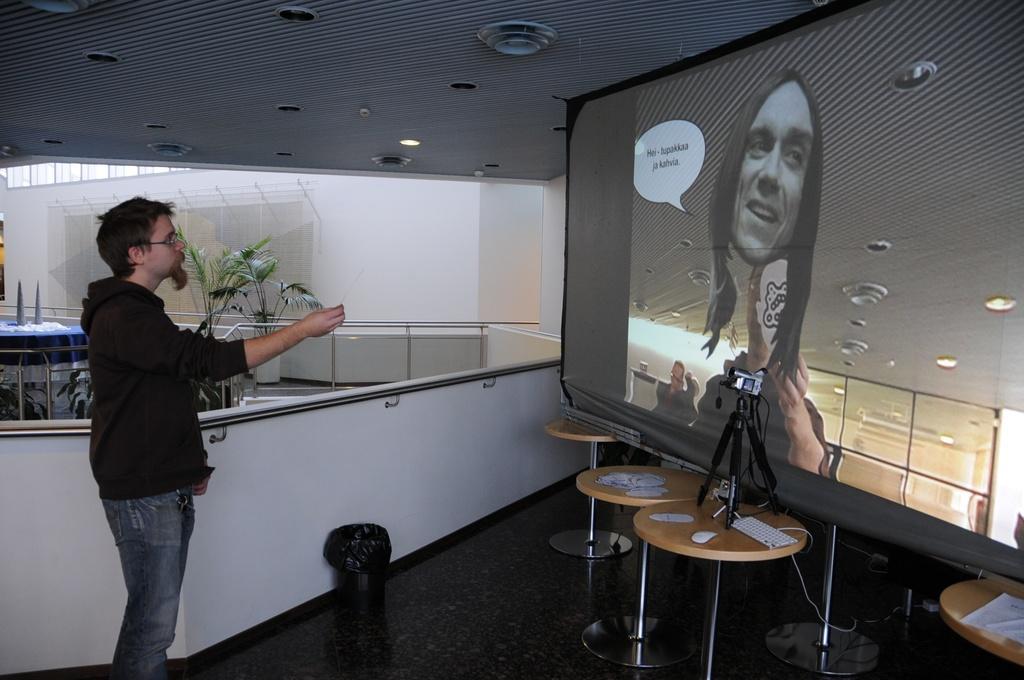Can you describe this image briefly? In this image, here we can see a person wearing black coat and jean which is also black in color and he is showing his hand towards a screen present in front of him. In the screen we can see 2 persons present and also another face popping which is not the real one, it may be some imaginary one and there are some tables present here and on these tables, screen is attached. There are flower pots present here, dustbin here. It seems like a furnished building. 